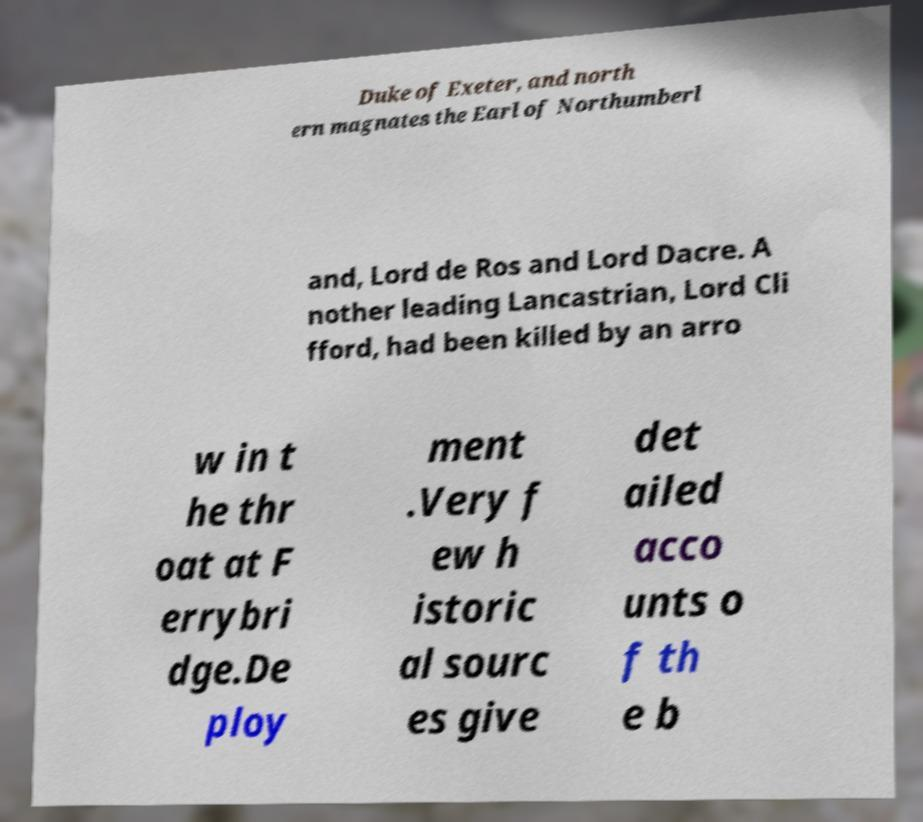Can you accurately transcribe the text from the provided image for me? Duke of Exeter, and north ern magnates the Earl of Northumberl and, Lord de Ros and Lord Dacre. A nother leading Lancastrian, Lord Cli fford, had been killed by an arro w in t he thr oat at F errybri dge.De ploy ment .Very f ew h istoric al sourc es give det ailed acco unts o f th e b 